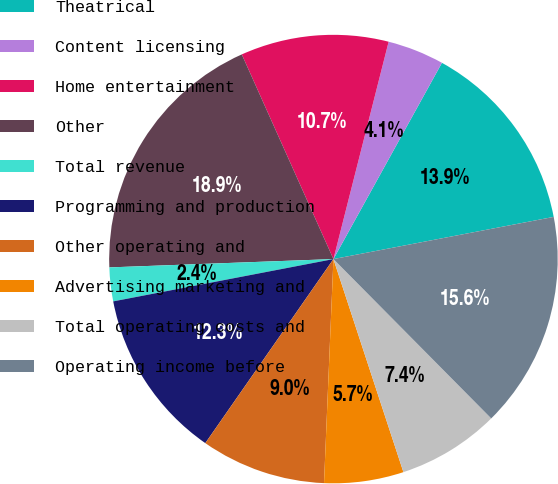Convert chart to OTSL. <chart><loc_0><loc_0><loc_500><loc_500><pie_chart><fcel>Theatrical<fcel>Content licensing<fcel>Home entertainment<fcel>Other<fcel>Total revenue<fcel>Programming and production<fcel>Other operating and<fcel>Advertising marketing and<fcel>Total operating costs and<fcel>Operating income before<nl><fcel>13.95%<fcel>4.08%<fcel>10.66%<fcel>18.89%<fcel>2.43%<fcel>12.3%<fcel>9.01%<fcel>5.72%<fcel>7.37%<fcel>15.59%<nl></chart> 